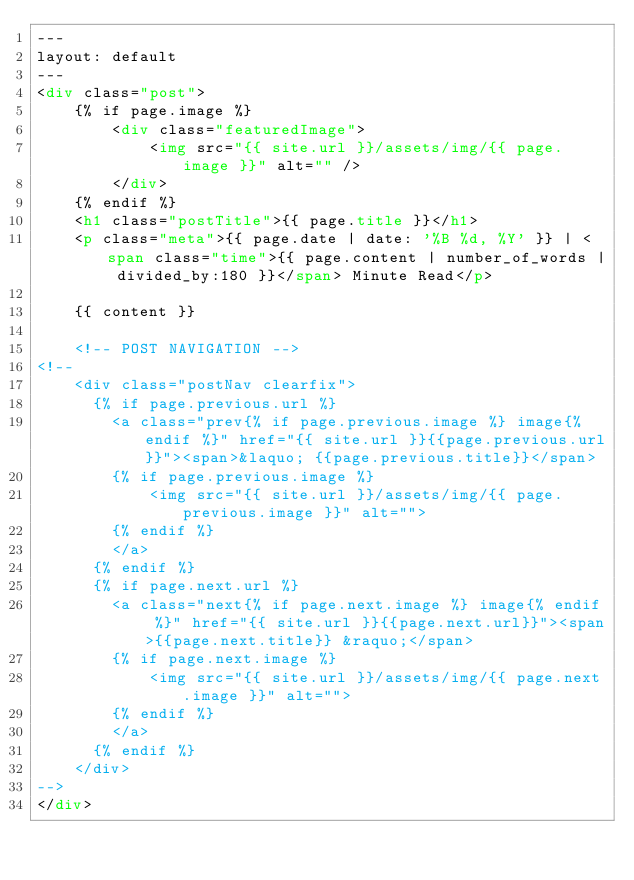Convert code to text. <code><loc_0><loc_0><loc_500><loc_500><_HTML_>---
layout: default
---
<div class="post">
	{% if page.image %}
		<div class="featuredImage">
	  		<img src="{{ site.url }}/assets/img/{{ page.image }}" alt="" />
	  	</div>
	{% endif %}
	<h1 class="postTitle">{{ page.title }}</h1>
	<p class="meta">{{ page.date | date: '%B %d, %Y' }} | <span class="time">{{ page.content | number_of_words | divided_by:180 }}</span> Minute Read</p>
	
	{{ content }}

	<!-- POST NAVIGATION -->
<!--
	<div class="postNav clearfix">
	  {% if page.previous.url %} 
	    <a class="prev{% if page.previous.image %} image{% endif %}" href="{{ site.url }}{{page.previous.url}}"><span>&laquo; {{page.previous.title}}</span>
	    {% if page.previous.image %} 
	    	<img src="{{ site.url }}/assets/img/{{ page.previous.image }}" alt="">
	    {% endif %}
		</a>
	  {% endif %}  
	  {% if page.next.url %}  
	    <a class="next{% if page.next.image %} image{% endif %}" href="{{ site.url }}{{page.next.url}}"><span>{{page.next.title}} &raquo;</span>
	    {% if page.next.image %} 
	    	<img src="{{ site.url }}/assets/img/{{ page.next.image }}" alt="">
	  	{% endif %} 
	  	</a>
	  {% endif %} 
	</div>
-->
</div>
</code> 